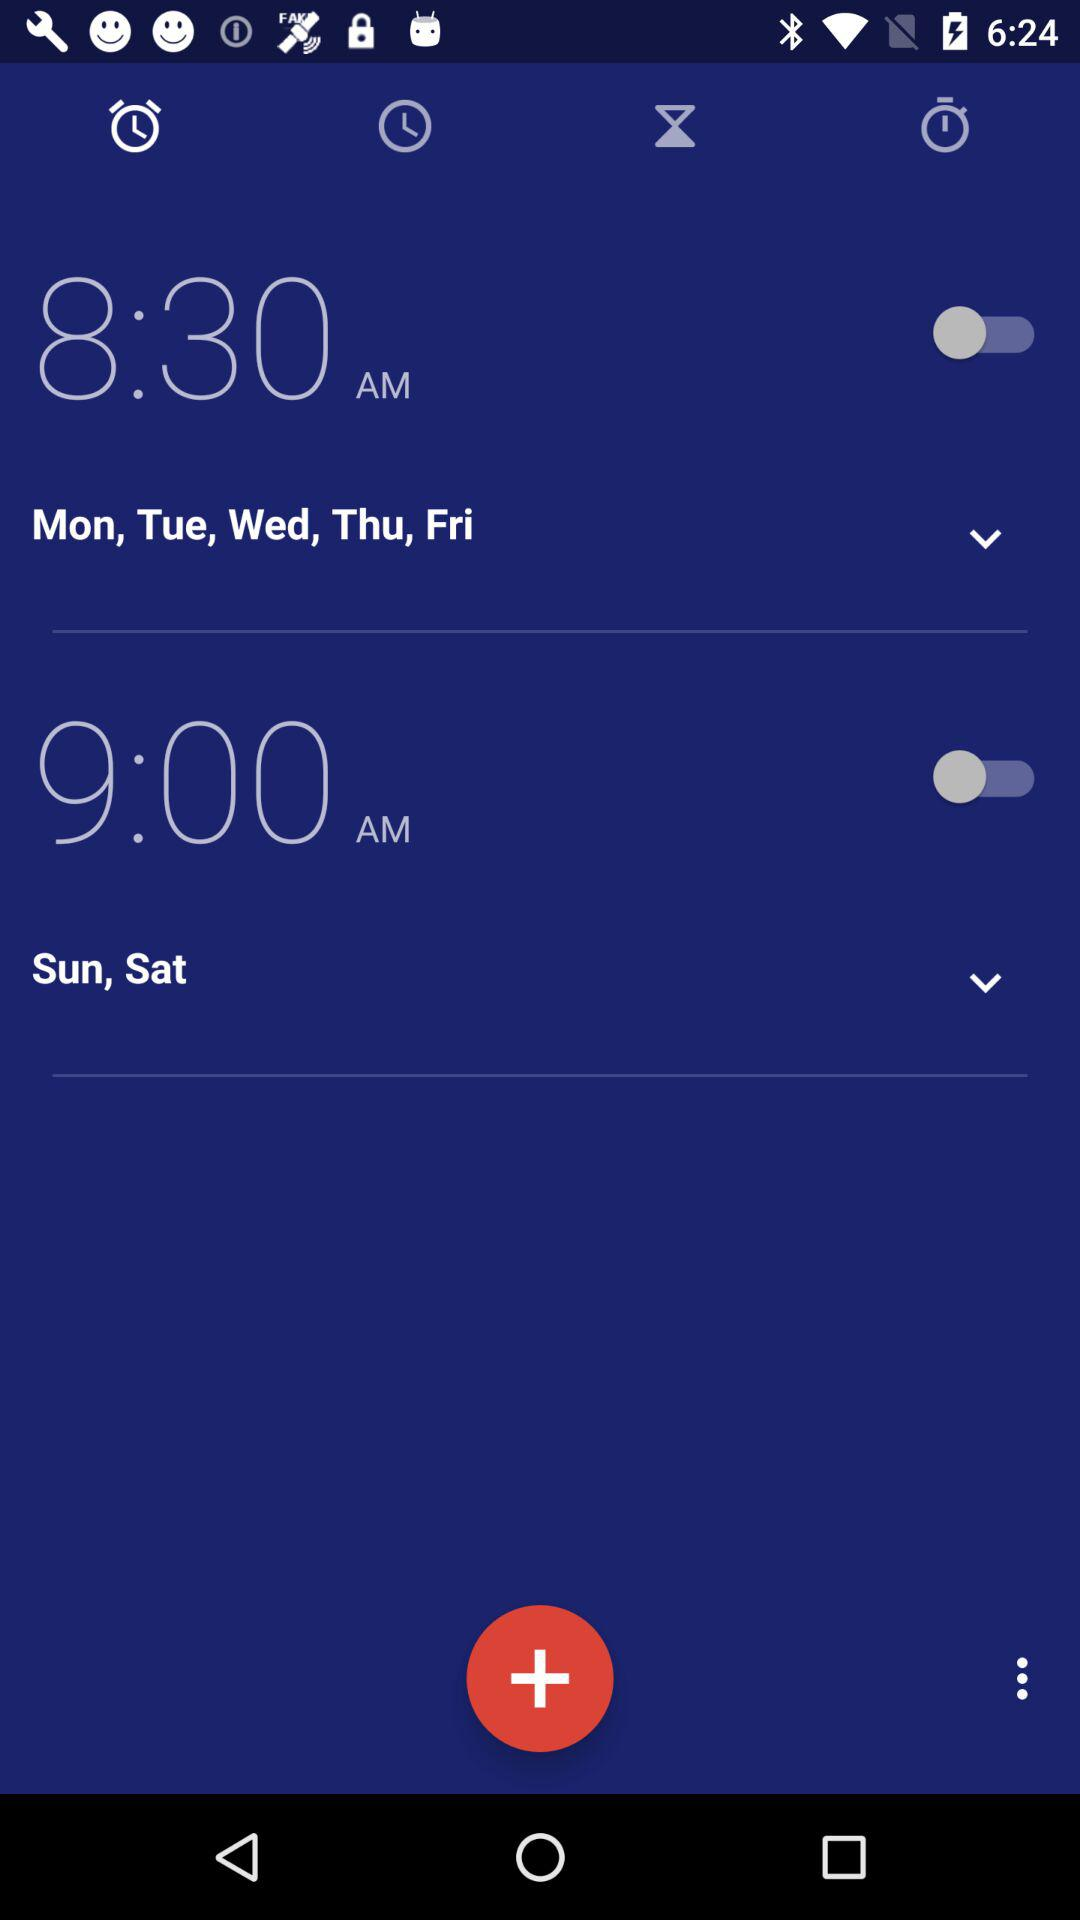What is the status of the "8:30 AM" alarm? The status is "off". 